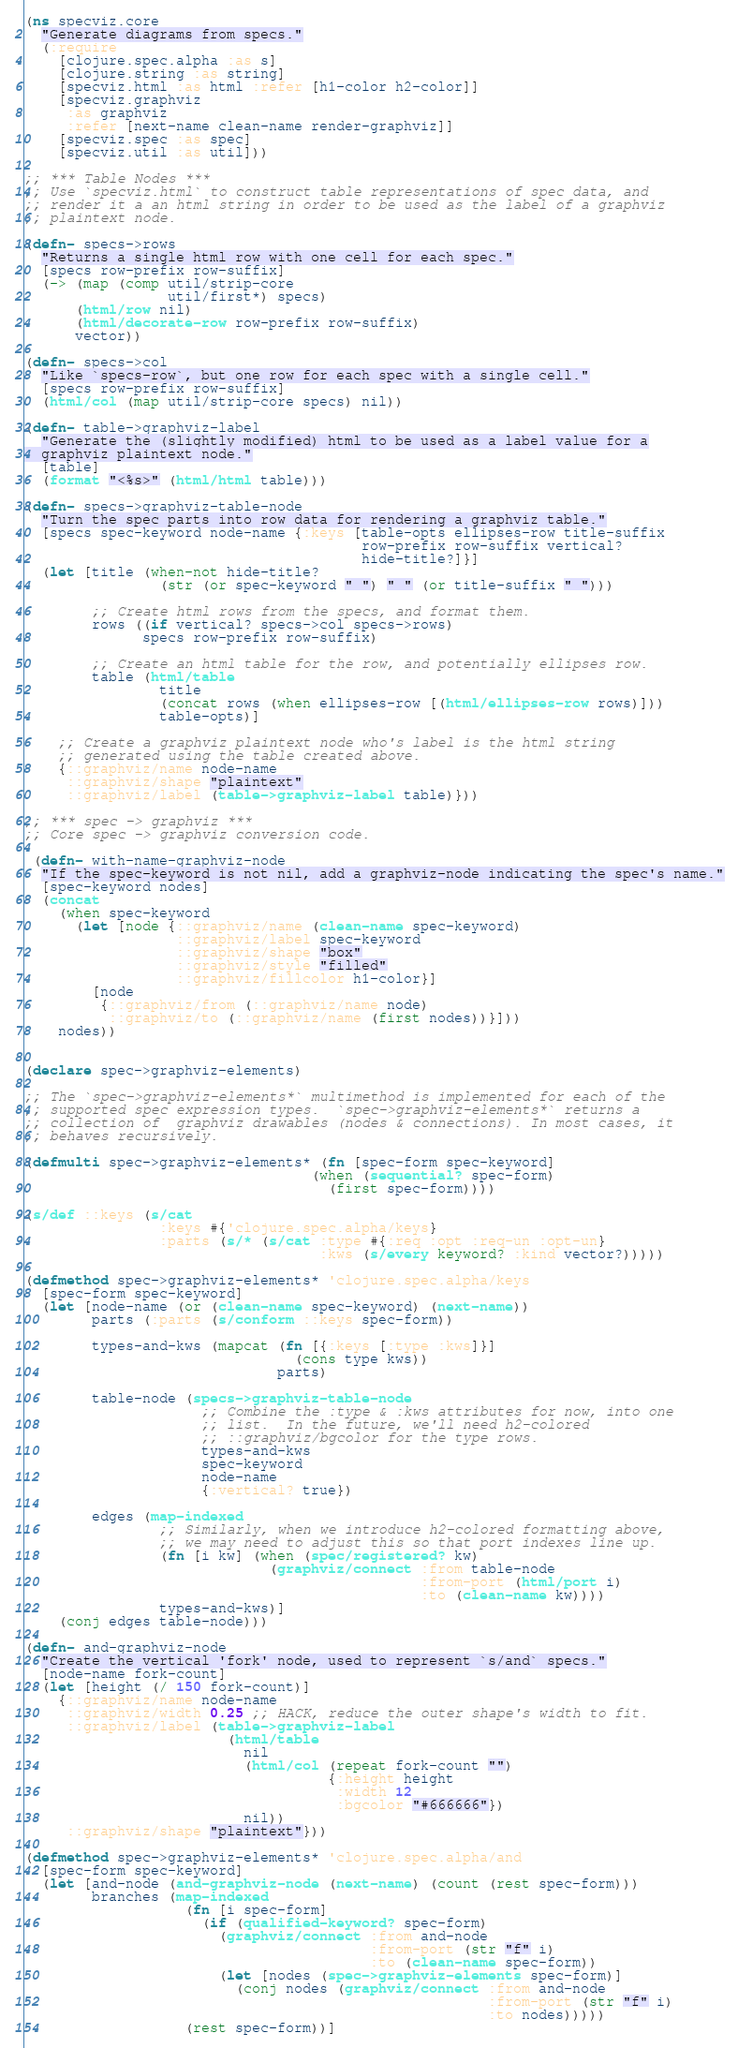<code> <loc_0><loc_0><loc_500><loc_500><_Clojure_>(ns specviz.core
  "Generate diagrams from specs."
  (:require
    [clojure.spec.alpha :as s]
    [clojure.string :as string]
    [specviz.html :as html :refer [h1-color h2-color]]
    [specviz.graphviz
     :as graphviz
     :refer [next-name clean-name render-graphviz]]
    [specviz.spec :as spec]
    [specviz.util :as util]))

;; *** Table Nodes ***
;; Use `specviz.html` to construct table representations of spec data, and
;; render it a an html string in order to be used as the label of a graphviz
;; plaintext node.

(defn- specs->rows
  "Returns a single html row with one cell for each spec."
  [specs row-prefix row-suffix]
  (-> (map (comp util/strip-core
                 util/first*) specs)
      (html/row nil)
      (html/decorate-row row-prefix row-suffix)
      vector))

(defn- specs->col
  "Like `specs-row`, but one row for each spec with a single cell."
  [specs row-prefix row-suffix]
  (html/col (map util/strip-core specs) nil))

(defn- table->graphviz-label
  "Generate the (slightly modified) html to be used as a label value for a
  graphviz plaintext node."
  [table]
  (format "<%s>" (html/html table)))

(defn- specs->graphviz-table-node
  "Turn the spec parts into row data for rendering a graphviz table."
  [specs spec-keyword node-name {:keys [table-opts ellipses-row title-suffix
                                        row-prefix row-suffix vertical?
                                        hide-title?]}]
  (let [title (when-not hide-title?
                (str (or spec-keyword " ") " " (or title-suffix " ")))

        ;; Create html rows from the specs, and format them.
        rows ((if vertical? specs->col specs->rows)
              specs row-prefix row-suffix)

        ;; Create an html table for the row, and potentially ellipses row.
        table (html/table
                title
                (concat rows (when ellipses-row [(html/ellipses-row rows)]))
                table-opts)]

    ;; Create a graphviz plaintext node who's label is the html string
    ;; generated using the table created above.
    {::graphviz/name node-name
     ::graphviz/shape "plaintext"
     ::graphviz/label (table->graphviz-label table)}))

;; *** spec -> graphviz ***
;; Core spec -> graphviz conversion code.

 (defn- with-name-graphviz-node
  "If the spec-keyword is not nil, add a graphviz-node indicating the spec's name."
  [spec-keyword nodes]
  (concat
    (when spec-keyword
      (let [node {::graphviz/name (clean-name spec-keyword)
                  ::graphviz/label spec-keyword
                  ::graphviz/shape "box"
                  ::graphviz/style "filled"
                  ::graphviz/fillcolor h1-color}]
        [node
         {::graphviz/from (::graphviz/name node)
          ::graphviz/to (::graphviz/name (first nodes))}]))
    nodes))


(declare spec->graphviz-elements)

;; The `spec->graphviz-elements*` multimethod is implemented for each of the
;; supported spec expression types.  `spec->graphviz-elements*` returns a
;; collection of  graphviz drawables (nodes & connections). In most cases, it
;; behaves recursively.

(defmulti spec->graphviz-elements* (fn [spec-form spec-keyword]
                                  (when (sequential? spec-form)
                                    (first spec-form))))

(s/def ::keys (s/cat
                :keys #{'clojure.spec.alpha/keys}
                :parts (s/* (s/cat :type #{:req :opt :req-un :opt-un}
                                   :kws (s/every keyword? :kind vector?)))))

(defmethod spec->graphviz-elements* 'clojure.spec.alpha/keys
  [spec-form spec-keyword]
  (let [node-name (or (clean-name spec-keyword) (next-name))
        parts (:parts (s/conform ::keys spec-form))

        types-and-kws (mapcat (fn [{:keys [:type :kws]}]
                                (cons type kws))
                              parts)

        table-node (specs->graphviz-table-node
                     ;; Combine the :type & :kws attributes for now, into one
                     ;; list.  In the future, we'll need h2-colored
                     ;; ::graphviz/bgcolor for the type rows.
                     types-and-kws
                     spec-keyword
                     node-name
                     {:vertical? true})

        edges (map-indexed
                ;; Similarly, when we introduce h2-colored formatting above,
                ;; we may need to adjust this so that port indexes line up.
                (fn [i kw] (when (spec/registered? kw)
                             (graphviz/connect :from table-node
                                               :from-port (html/port i)
                                               :to (clean-name kw))))
                types-and-kws)]
    (conj edges table-node)))

(defn- and-graphviz-node
  "Create the vertical 'fork' node, used to represent `s/and` specs."
  [node-name fork-count]
  (let [height (/ 150 fork-count)]
    {::graphviz/name node-name
     ::graphviz/width 0.25 ;; HACK, reduce the outer shape's width to fit.
     ::graphviz/label (table->graphviz-label
                        (html/table
                          nil
                          (html/col (repeat fork-count "")
                                    {:height height
                                     :width 12
                                     :bgcolor "#666666"})
                          nil))
     ::graphviz/shape "plaintext"}))

(defmethod spec->graphviz-elements* 'clojure.spec.alpha/and
  [spec-form spec-keyword]
  (let [and-node (and-graphviz-node (next-name) (count (rest spec-form)))
        branches (map-indexed
                   (fn [i spec-form]
                     (if (qualified-keyword? spec-form)
                       (graphviz/connect :from and-node
                                         :from-port (str "f" i)
                                         :to (clean-name spec-form))
                       (let [nodes (spec->graphviz-elements spec-form)]
                         (conj nodes (graphviz/connect :from and-node
                                                       :from-port (str "f" i)
                                                       :to nodes)))))
                   (rest spec-form))]</code> 